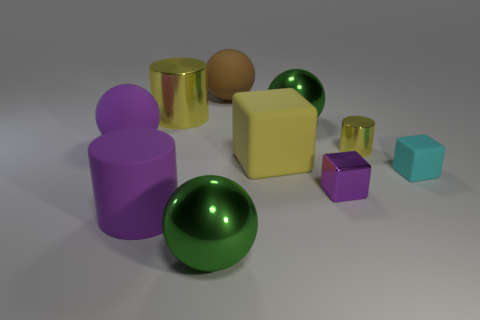There is a tiny object that is the same color as the large cube; what shape is it?
Give a very brief answer. Cylinder. There is a block that is the same color as the big metal cylinder; what size is it?
Keep it short and to the point. Large. There is a large ball that is both left of the large brown rubber ball and to the right of the large purple cylinder; what color is it?
Your answer should be very brief. Green. Do the metallic cylinder that is right of the big yellow cylinder and the big metallic cylinder have the same color?
Ensure brevity in your answer.  Yes. How many balls are purple objects or big rubber objects?
Keep it short and to the point. 2. What shape is the green metal thing that is to the left of the brown object?
Give a very brief answer. Sphere. There is a large rubber ball that is behind the big metallic object that is to the left of the large green sphere that is in front of the big purple cylinder; what color is it?
Offer a very short reply. Brown. Is the material of the small cylinder the same as the large block?
Provide a short and direct response. No. How many cyan objects are either big matte spheres or big cubes?
Give a very brief answer. 0. There is a big yellow cylinder; what number of large rubber spheres are on the right side of it?
Provide a succinct answer. 1. 